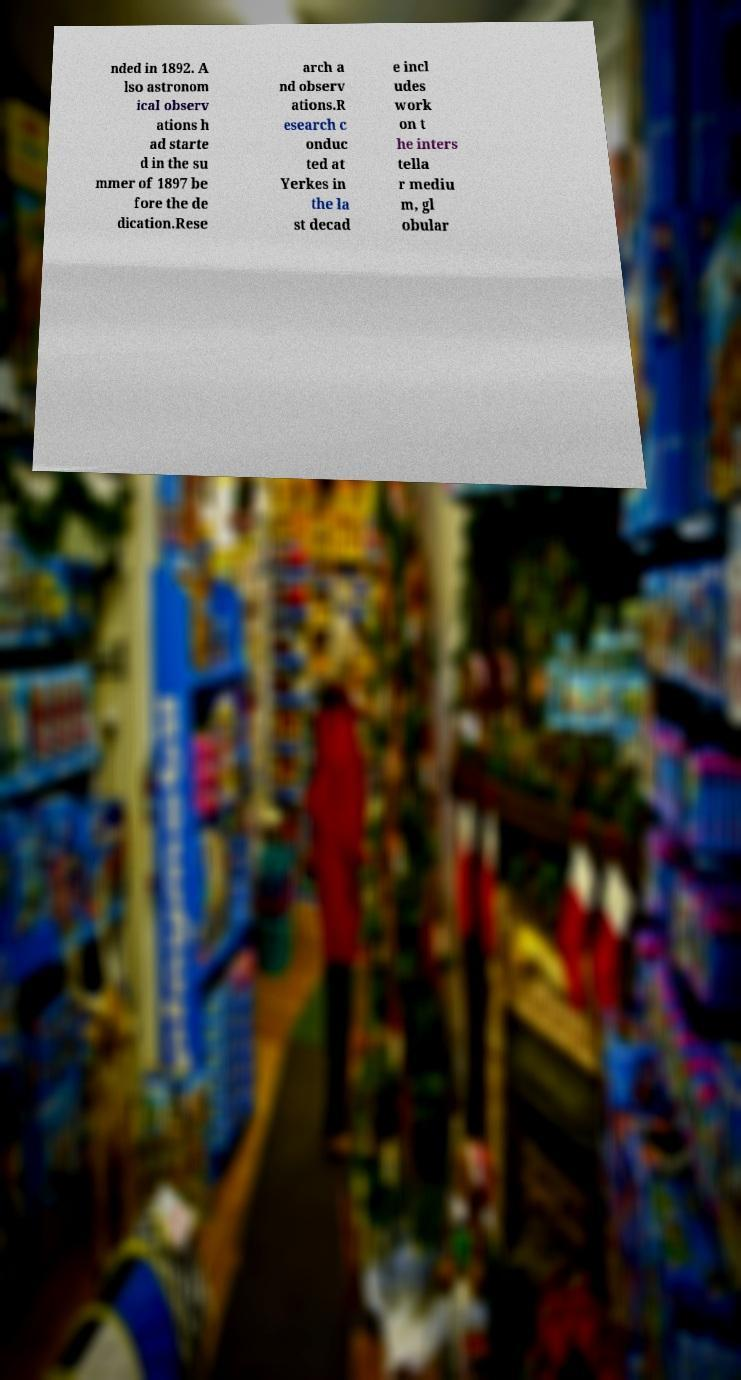Please identify and transcribe the text found in this image. nded in 1892. A lso astronom ical observ ations h ad starte d in the su mmer of 1897 be fore the de dication.Rese arch a nd observ ations.R esearch c onduc ted at Yerkes in the la st decad e incl udes work on t he inters tella r mediu m, gl obular 